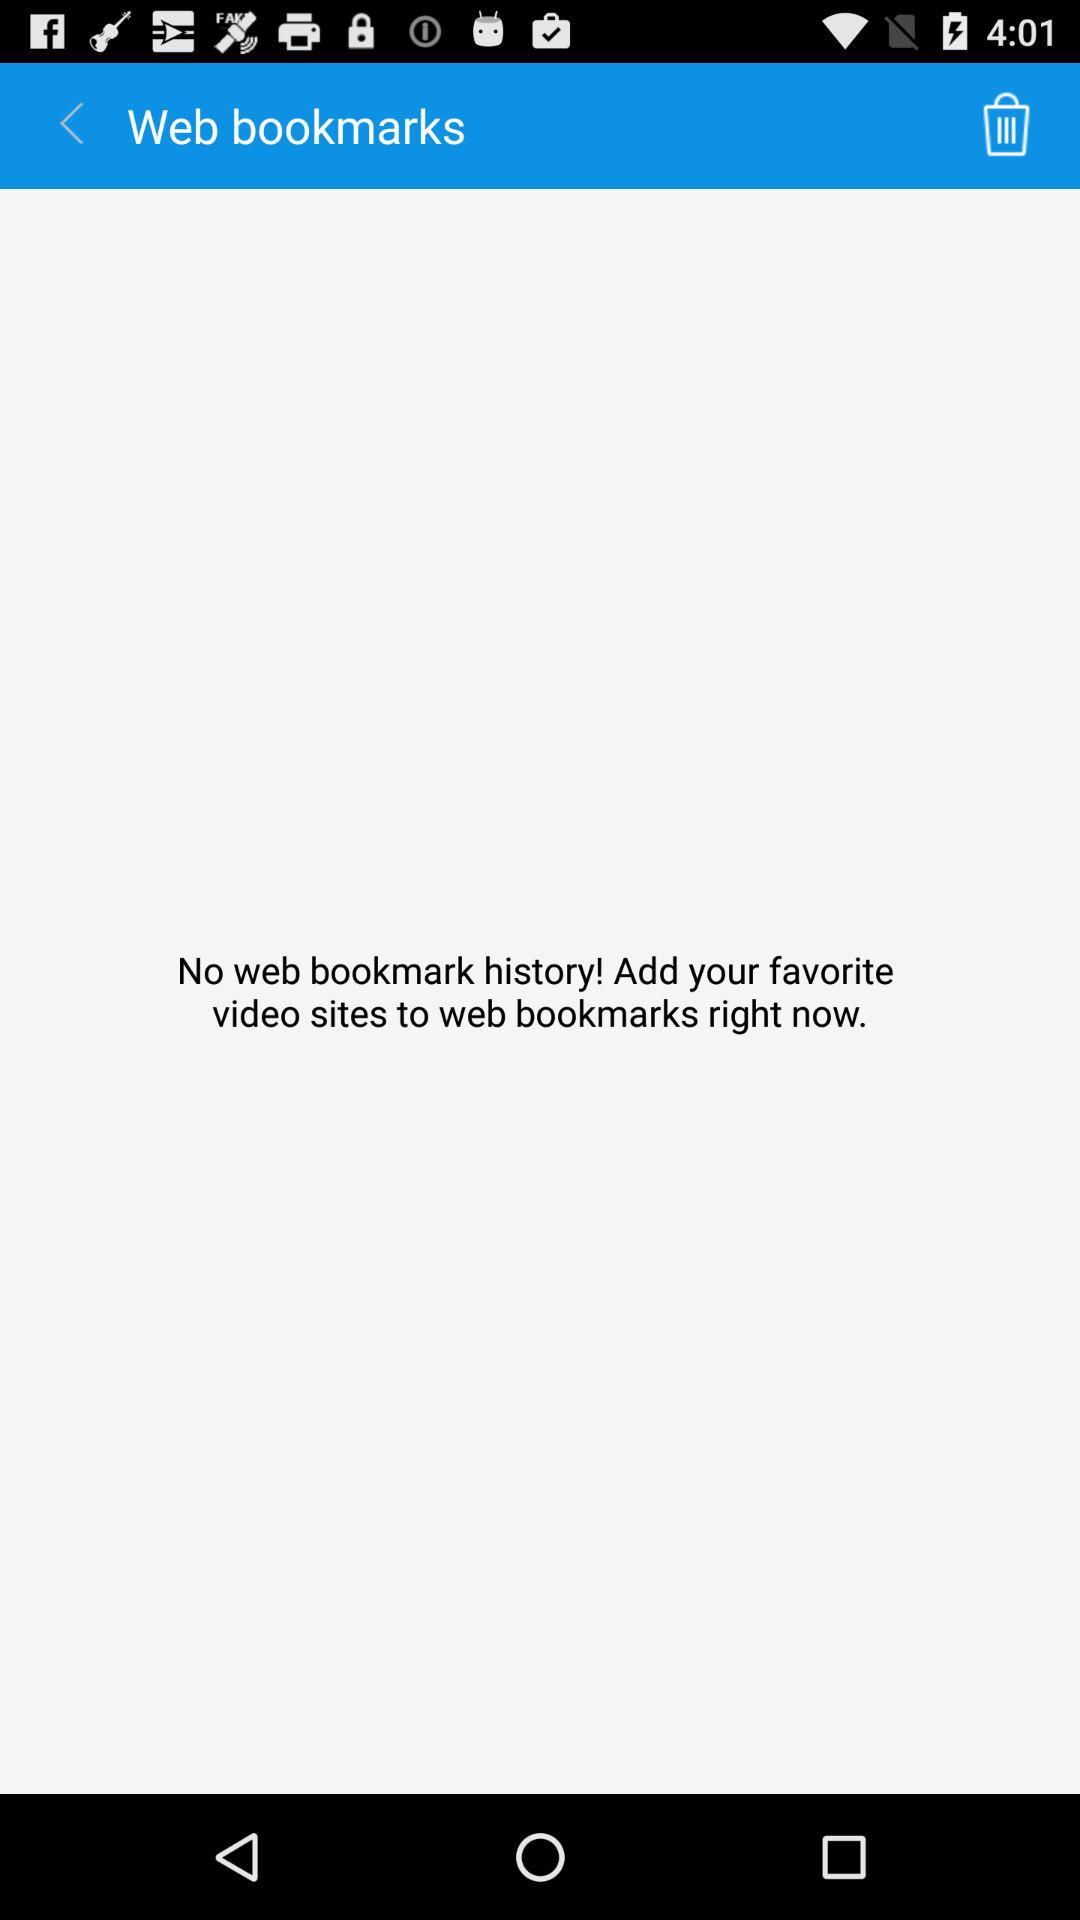How many bookmarks does the user have?
Answer the question using a single word or phrase. 0 